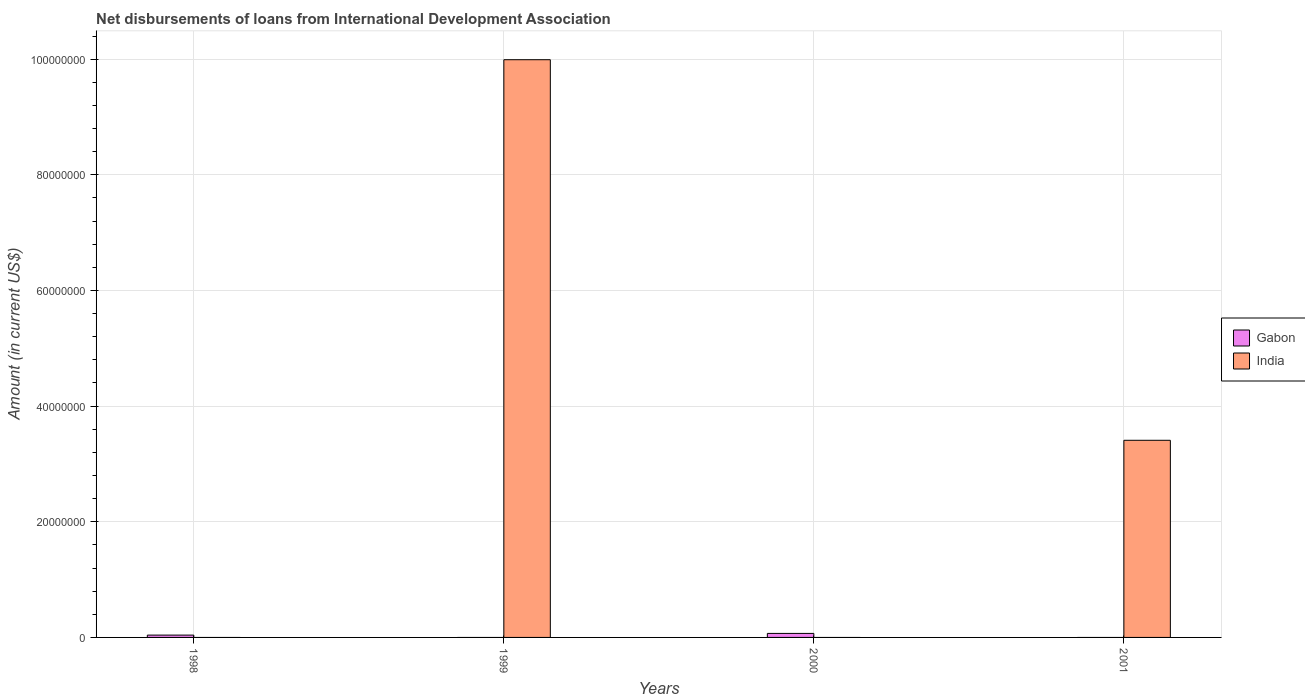How many different coloured bars are there?
Offer a very short reply. 2. Are the number of bars on each tick of the X-axis equal?
Offer a terse response. Yes. What is the amount of loans disbursed in Gabon in 2001?
Make the answer very short. 0. Across all years, what is the maximum amount of loans disbursed in India?
Offer a terse response. 9.99e+07. What is the total amount of loans disbursed in Gabon in the graph?
Keep it short and to the point. 1.10e+06. What is the difference between the amount of loans disbursed in Gabon in 1998 and that in 2000?
Provide a short and direct response. -2.93e+05. What is the difference between the amount of loans disbursed in Gabon in 1998 and the amount of loans disbursed in India in 2001?
Ensure brevity in your answer.  -3.37e+07. What is the average amount of loans disbursed in India per year?
Your response must be concise. 3.35e+07. What is the difference between the highest and the lowest amount of loans disbursed in Gabon?
Your answer should be compact. 6.94e+05. Is the sum of the amount of loans disbursed in Gabon in 1998 and 2000 greater than the maximum amount of loans disbursed in India across all years?
Make the answer very short. No. How many bars are there?
Make the answer very short. 4. Are all the bars in the graph horizontal?
Provide a short and direct response. No. How many years are there in the graph?
Give a very brief answer. 4. Does the graph contain any zero values?
Your answer should be very brief. Yes. Where does the legend appear in the graph?
Your response must be concise. Center right. How many legend labels are there?
Offer a terse response. 2. What is the title of the graph?
Your response must be concise. Net disbursements of loans from International Development Association. Does "Turkey" appear as one of the legend labels in the graph?
Offer a very short reply. No. What is the label or title of the Y-axis?
Your response must be concise. Amount (in current US$). What is the Amount (in current US$) of Gabon in 1998?
Your answer should be very brief. 4.01e+05. What is the Amount (in current US$) in India in 1998?
Offer a very short reply. 0. What is the Amount (in current US$) in Gabon in 1999?
Your answer should be very brief. 0. What is the Amount (in current US$) of India in 1999?
Give a very brief answer. 9.99e+07. What is the Amount (in current US$) of Gabon in 2000?
Make the answer very short. 6.94e+05. What is the Amount (in current US$) of India in 2001?
Give a very brief answer. 3.41e+07. Across all years, what is the maximum Amount (in current US$) of Gabon?
Ensure brevity in your answer.  6.94e+05. Across all years, what is the maximum Amount (in current US$) in India?
Make the answer very short. 9.99e+07. Across all years, what is the minimum Amount (in current US$) of India?
Ensure brevity in your answer.  0. What is the total Amount (in current US$) of Gabon in the graph?
Offer a very short reply. 1.10e+06. What is the total Amount (in current US$) in India in the graph?
Your response must be concise. 1.34e+08. What is the difference between the Amount (in current US$) of Gabon in 1998 and that in 2000?
Give a very brief answer. -2.93e+05. What is the difference between the Amount (in current US$) of India in 1999 and that in 2001?
Make the answer very short. 6.58e+07. What is the difference between the Amount (in current US$) in Gabon in 1998 and the Amount (in current US$) in India in 1999?
Make the answer very short. -9.95e+07. What is the difference between the Amount (in current US$) in Gabon in 1998 and the Amount (in current US$) in India in 2001?
Provide a short and direct response. -3.37e+07. What is the difference between the Amount (in current US$) of Gabon in 2000 and the Amount (in current US$) of India in 2001?
Provide a succinct answer. -3.34e+07. What is the average Amount (in current US$) of Gabon per year?
Offer a very short reply. 2.74e+05. What is the average Amount (in current US$) of India per year?
Offer a terse response. 3.35e+07. What is the ratio of the Amount (in current US$) of Gabon in 1998 to that in 2000?
Ensure brevity in your answer.  0.58. What is the ratio of the Amount (in current US$) in India in 1999 to that in 2001?
Offer a terse response. 2.93. What is the difference between the highest and the lowest Amount (in current US$) in Gabon?
Offer a terse response. 6.94e+05. What is the difference between the highest and the lowest Amount (in current US$) of India?
Offer a very short reply. 9.99e+07. 